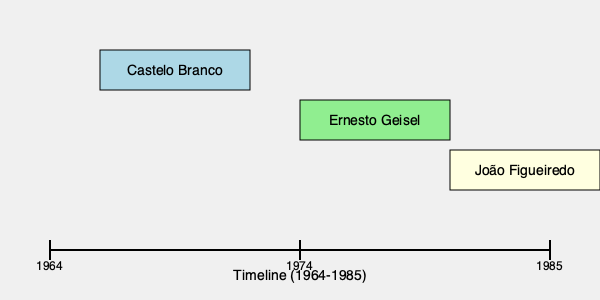Match the Brazilian military dictatorship presidents to their correct positions on the timeline, considering that Castelo Branco was the first president of the regime, Ernesto Geisel initiated the gradual democratization process, and João Figueiredo was the last military president. 1. The Brazilian military dictatorship lasted from 1964 to 1985.
2. Humberto de Alencar Castelo Branco was the first president of the military regime, taking power in 1964. Therefore, his position on the timeline should be at the beginning, closest to 1964.
3. Ernesto Geisel became president in 1974 and initiated the gradual democratization process known as "distensão" (relaxation). His position should be in the middle of the timeline, around 1974.
4. João Figueiredo was the last military president, ruling from 1979 to 1985. His position should be at the end of the timeline, closest to 1985.
5. The graphic correctly shows Castelo Branco at the beginning (left), Geisel in the middle, and Figueiredo at the end (right) of the timeline.
Answer: Correct positioning 